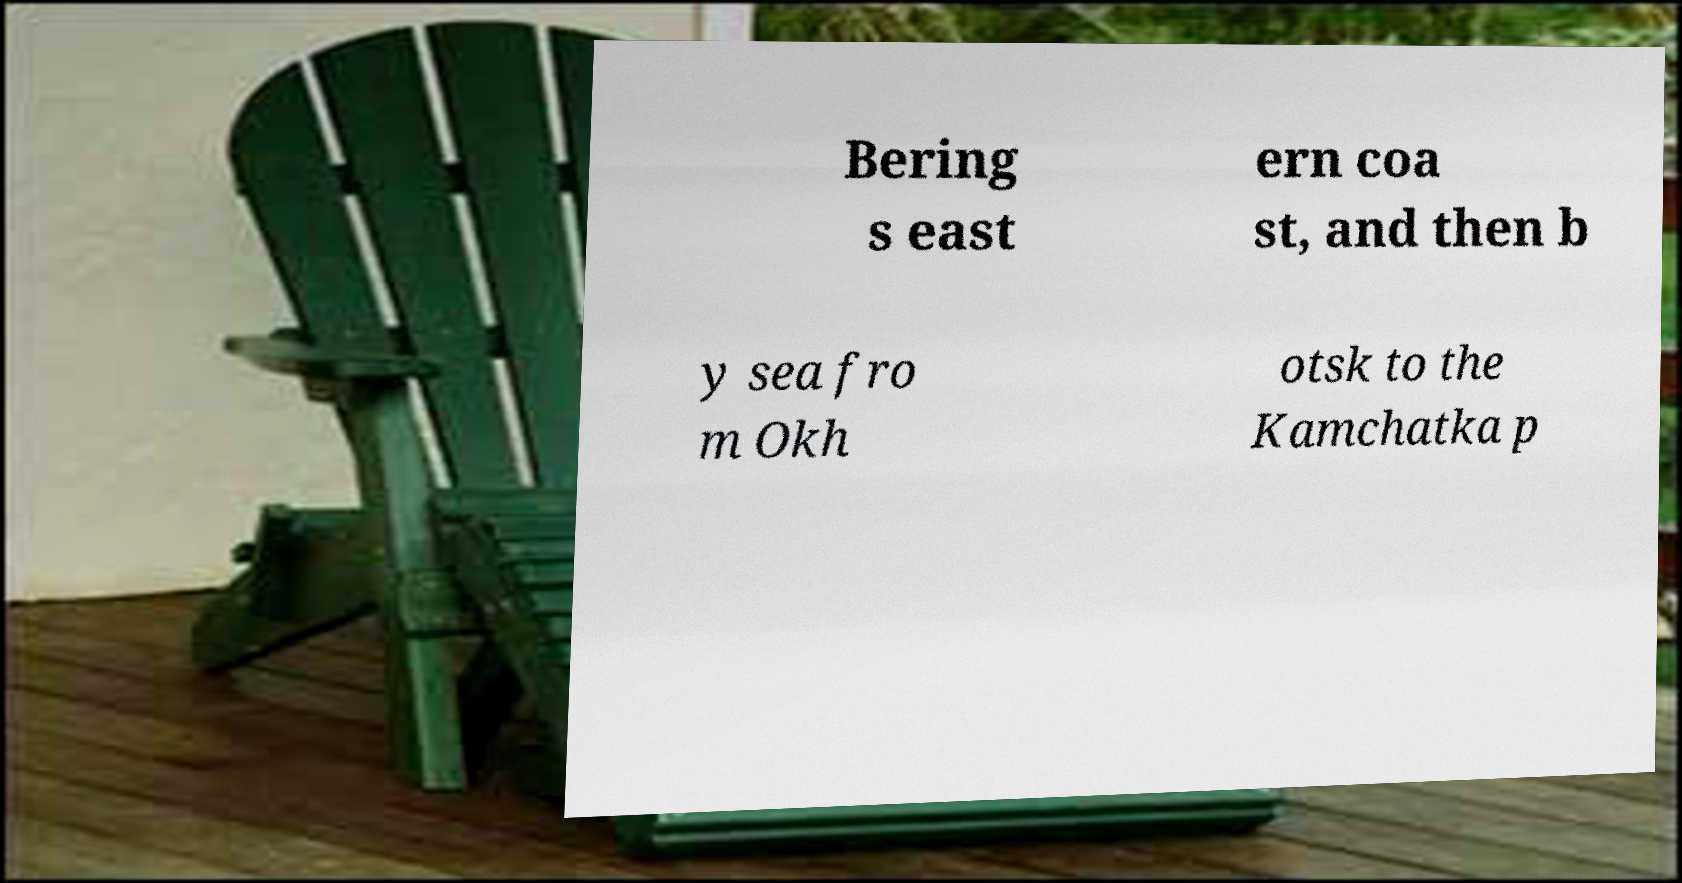For documentation purposes, I need the text within this image transcribed. Could you provide that? Bering s east ern coa st, and then b y sea fro m Okh otsk to the Kamchatka p 